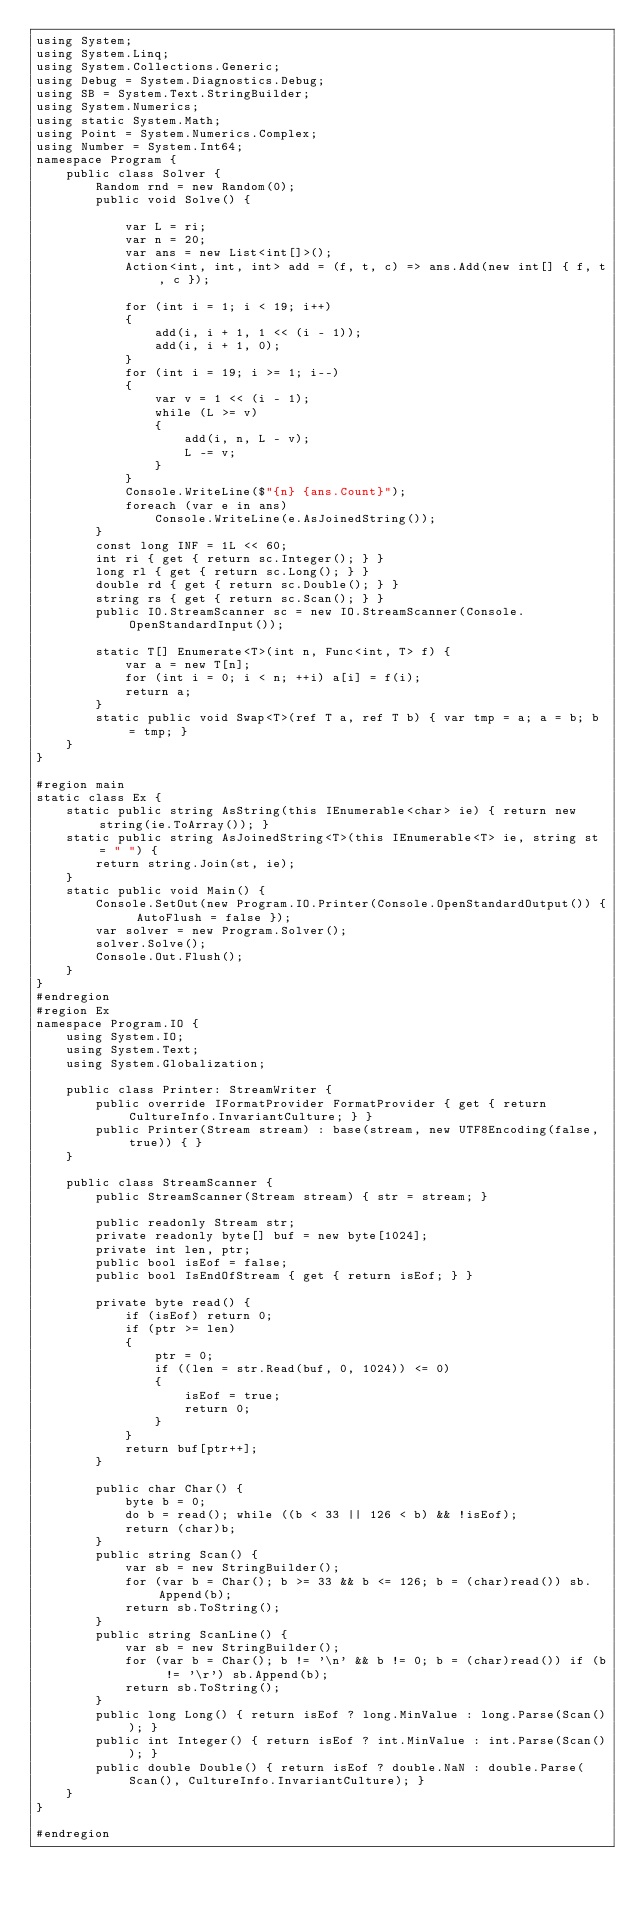<code> <loc_0><loc_0><loc_500><loc_500><_C#_>using System;
using System.Linq;
using System.Collections.Generic;
using Debug = System.Diagnostics.Debug;
using SB = System.Text.StringBuilder;
using System.Numerics;
using static System.Math;
using Point = System.Numerics.Complex;
using Number = System.Int64;
namespace Program {
    public class Solver {
        Random rnd = new Random(0);
        public void Solve() {

            var L = ri;
            var n = 20;
            var ans = new List<int[]>();
            Action<int, int, int> add = (f, t, c) => ans.Add(new int[] { f, t, c });

            for (int i = 1; i < 19; i++)
            {
                add(i, i + 1, 1 << (i - 1));
                add(i, i + 1, 0);
            }
            for (int i = 19; i >= 1; i--)
            {
                var v = 1 << (i - 1);
                while (L >= v)
                {
                    add(i, n, L - v);
                    L -= v;
                }
            }
            Console.WriteLine($"{n} {ans.Count}");
            foreach (var e in ans)
                Console.WriteLine(e.AsJoinedString());
        }
        const long INF = 1L << 60;
        int ri { get { return sc.Integer(); } }
        long rl { get { return sc.Long(); } }
        double rd { get { return sc.Double(); } }
        string rs { get { return sc.Scan(); } }
        public IO.StreamScanner sc = new IO.StreamScanner(Console.OpenStandardInput());

        static T[] Enumerate<T>(int n, Func<int, T> f) {
            var a = new T[n];
            for (int i = 0; i < n; ++i) a[i] = f(i);
            return a;
        }
        static public void Swap<T>(ref T a, ref T b) { var tmp = a; a = b; b = tmp; }
    }
}

#region main
static class Ex {
    static public string AsString(this IEnumerable<char> ie) { return new string(ie.ToArray()); }
    static public string AsJoinedString<T>(this IEnumerable<T> ie, string st = " ") {
        return string.Join(st, ie);
    }
    static public void Main() {
        Console.SetOut(new Program.IO.Printer(Console.OpenStandardOutput()) { AutoFlush = false });
        var solver = new Program.Solver();
        solver.Solve();
        Console.Out.Flush();
    }
}
#endregion
#region Ex
namespace Program.IO {
    using System.IO;
    using System.Text;
    using System.Globalization;

    public class Printer: StreamWriter {
        public override IFormatProvider FormatProvider { get { return CultureInfo.InvariantCulture; } }
        public Printer(Stream stream) : base(stream, new UTF8Encoding(false, true)) { }
    }

    public class StreamScanner {
        public StreamScanner(Stream stream) { str = stream; }

        public readonly Stream str;
        private readonly byte[] buf = new byte[1024];
        private int len, ptr;
        public bool isEof = false;
        public bool IsEndOfStream { get { return isEof; } }

        private byte read() {
            if (isEof) return 0;
            if (ptr >= len)
            {
                ptr = 0;
                if ((len = str.Read(buf, 0, 1024)) <= 0)
                {
                    isEof = true;
                    return 0;
                }
            }
            return buf[ptr++];
        }

        public char Char() {
            byte b = 0;
            do b = read(); while ((b < 33 || 126 < b) && !isEof);
            return (char)b;
        }
        public string Scan() {
            var sb = new StringBuilder();
            for (var b = Char(); b >= 33 && b <= 126; b = (char)read()) sb.Append(b);
            return sb.ToString();
        }
        public string ScanLine() {
            var sb = new StringBuilder();
            for (var b = Char(); b != '\n' && b != 0; b = (char)read()) if (b != '\r') sb.Append(b);
            return sb.ToString();
        }
        public long Long() { return isEof ? long.MinValue : long.Parse(Scan()); }
        public int Integer() { return isEof ? int.MinValue : int.Parse(Scan()); }
        public double Double() { return isEof ? double.NaN : double.Parse(Scan(), CultureInfo.InvariantCulture); }
    }
}

#endregion

</code> 